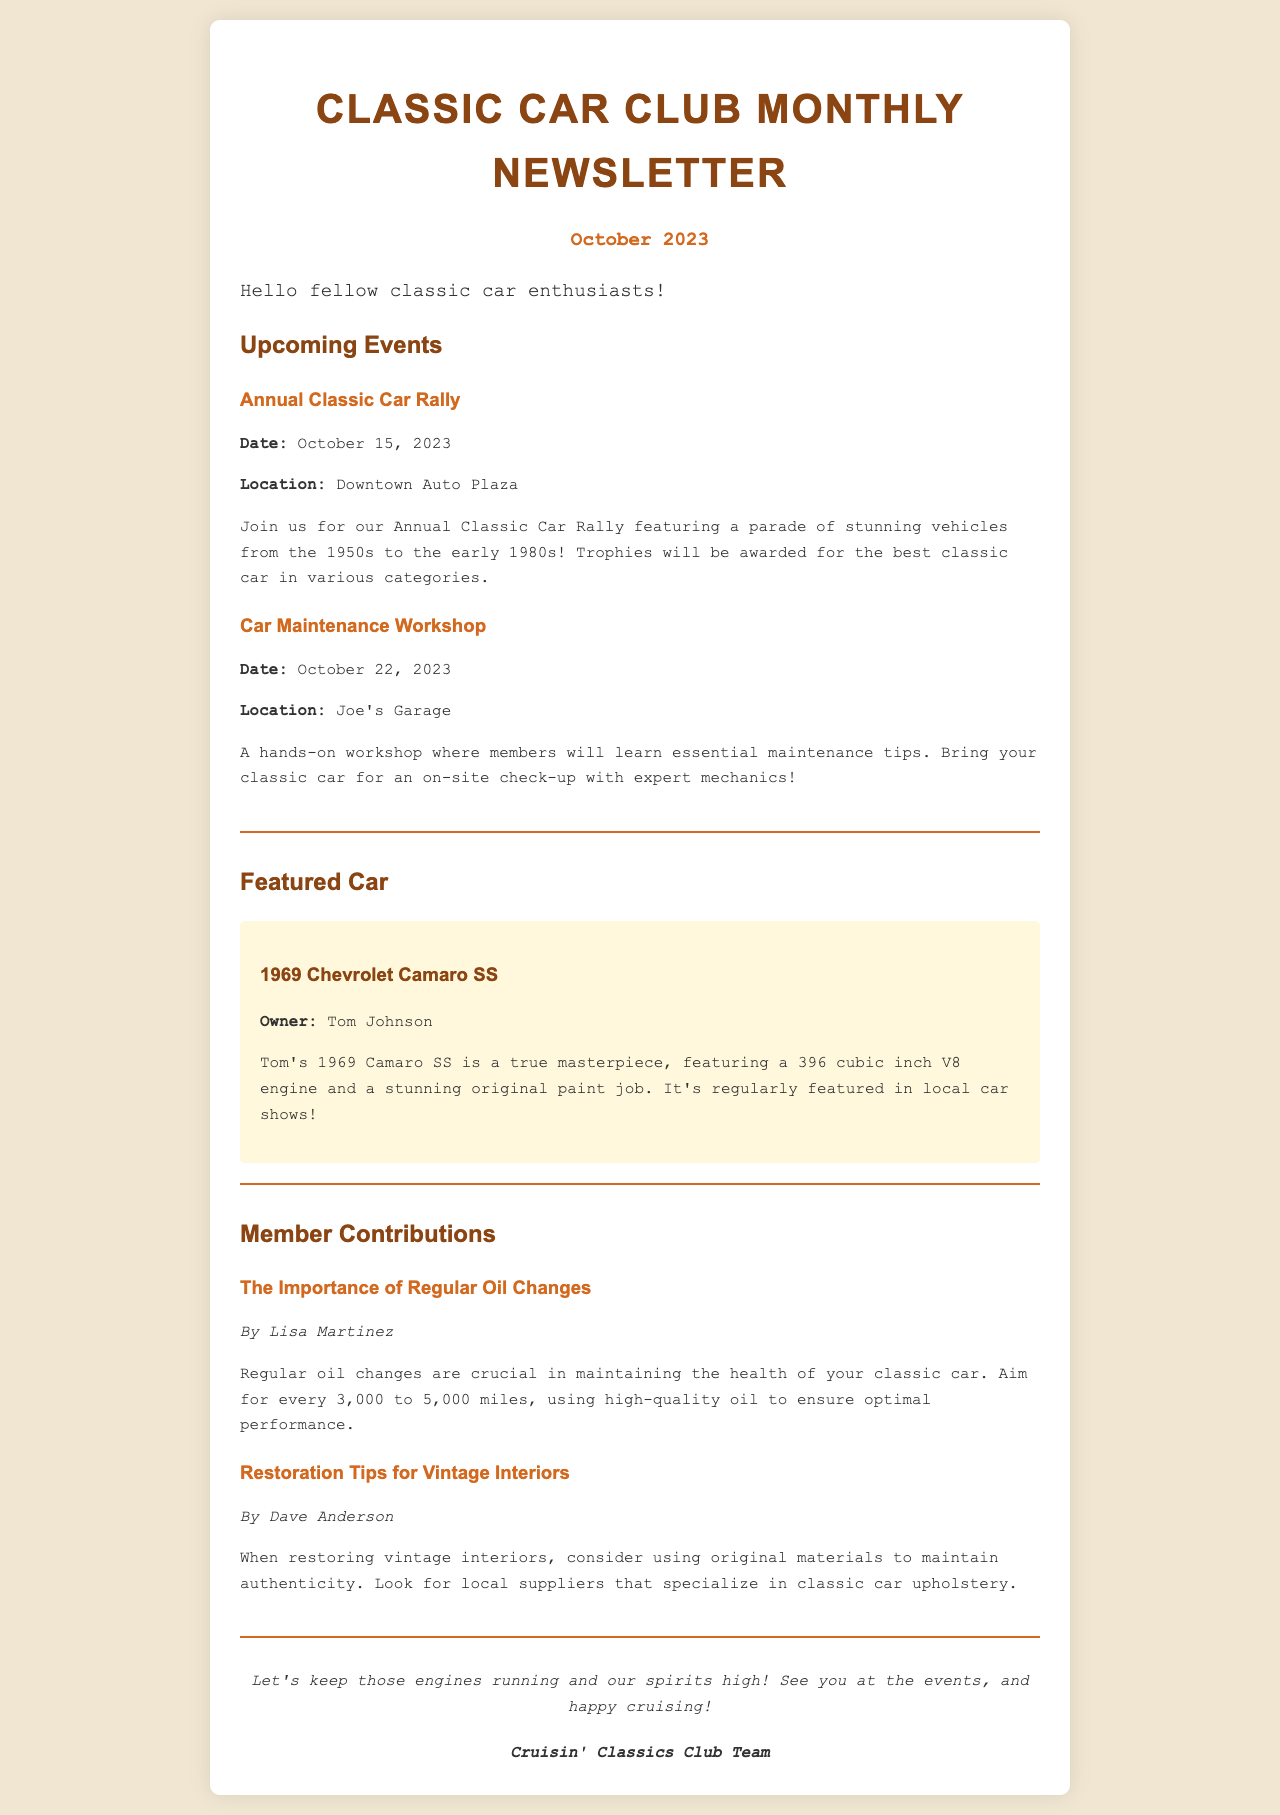What is the date of the Annual Classic Car Rally? The document specifies the date for the Annual Classic Car Rally as October 15, 2023.
Answer: October 15, 2023 Where will the Car Maintenance Workshop be held? The location for the Car Maintenance Workshop is mentioned as Joe's Garage.
Answer: Joe's Garage Who is the owner of the featured car? The document states that the owner of the 1969 Chevrolet Camaro SS is Tom Johnson.
Answer: Tom Johnson What is one maintenance tip mentioned by Lisa Martinez? Lisa Martinez emphasizes the importance of regular oil changes every 3,000 to 5,000 miles using high-quality oil.
Answer: Regular oil changes What car model is featured in the newsletter? The newsletter features a 1969 Chevrolet Camaro SS in its section about the featured car.
Answer: 1969 Chevrolet Camaro SS How many events are listed in the newsletter? Two events are detailed in the Upcoming Events section: the Annual Classic Car Rally and the Car Maintenance Workshop.
Answer: Two What is the main focus of the Car Maintenance Workshop? The primary purpose of the Car Maintenance Workshop is to teach essential maintenance tips with hands-on experience.
Answer: Essential maintenance tips Who contributed tips for restoring vintage interiors? The contribution about restoration tips for vintage interiors is credited to Dave Anderson.
Answer: Dave Anderson 